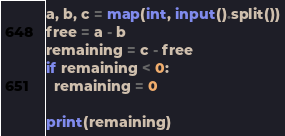<code> <loc_0><loc_0><loc_500><loc_500><_Python_>a, b, c = map(int, input().split())
free = a - b
remaining = c - free
if remaining < 0:
  remaining = 0

print(remaining)</code> 